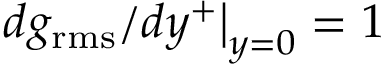<formula> <loc_0><loc_0><loc_500><loc_500>d g _ { r m s } / d y ^ { + } \right | _ { y = 0 } = 1</formula> 